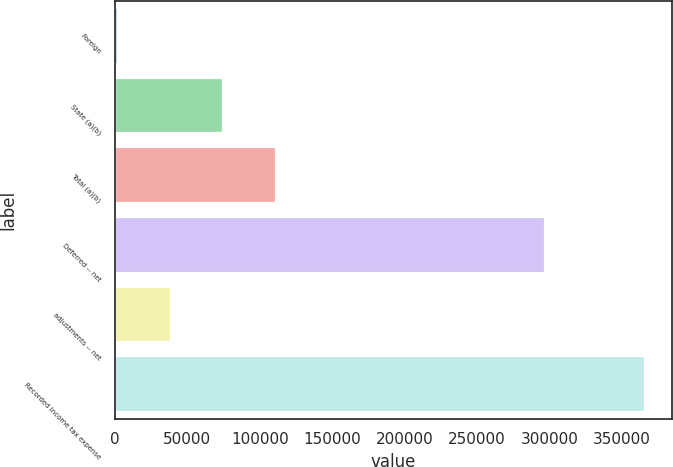Convert chart. <chart><loc_0><loc_0><loc_500><loc_500><bar_chart><fcel>Foreign<fcel>State (a)(b)<fcel>Total (a)(b)<fcel>Deferred -- net<fcel>adjustments -- net<fcel>Recorded income tax expense<nl><fcel>2231<fcel>74966.4<fcel>111334<fcel>296445<fcel>38598.7<fcel>365908<nl></chart> 